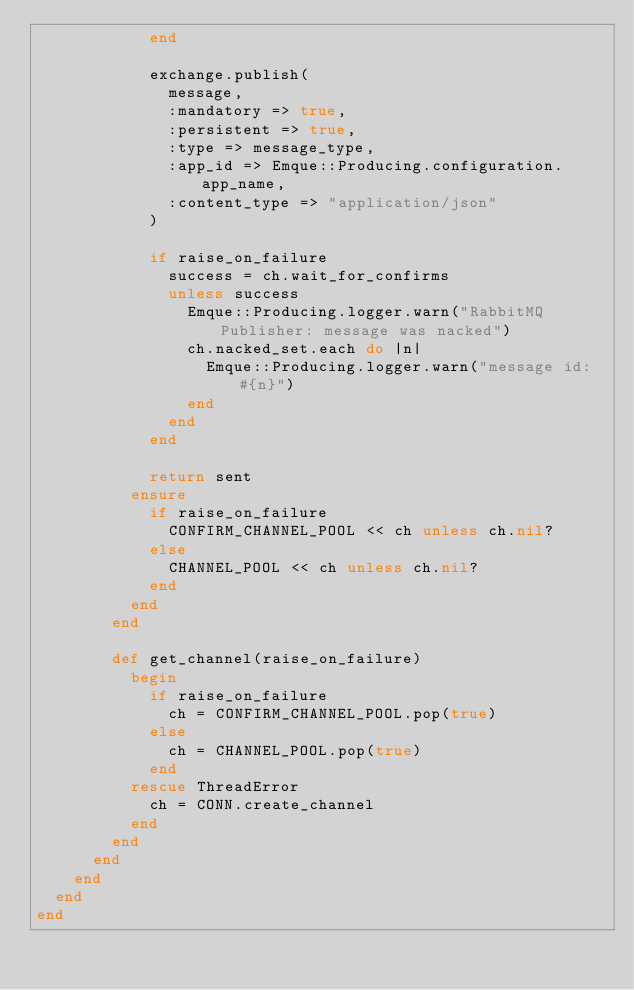<code> <loc_0><loc_0><loc_500><loc_500><_Ruby_>            end

            exchange.publish(
              message,
              :mandatory => true,
              :persistent => true,
              :type => message_type,
              :app_id => Emque::Producing.configuration.app_name,
              :content_type => "application/json"
            )

            if raise_on_failure
              success = ch.wait_for_confirms
              unless success
                Emque::Producing.logger.warn("RabbitMQ Publisher: message was nacked")
                ch.nacked_set.each do |n|
                  Emque::Producing.logger.warn("message id: #{n}")
                end
              end
            end

            return sent
          ensure
            if raise_on_failure
              CONFIRM_CHANNEL_POOL << ch unless ch.nil?
            else
              CHANNEL_POOL << ch unless ch.nil?
            end
          end
        end

        def get_channel(raise_on_failure)
          begin
            if raise_on_failure
              ch = CONFIRM_CHANNEL_POOL.pop(true)
            else
              ch = CHANNEL_POOL.pop(true)
            end
          rescue ThreadError
            ch = CONN.create_channel
          end
        end
      end
    end
  end
end
</code> 